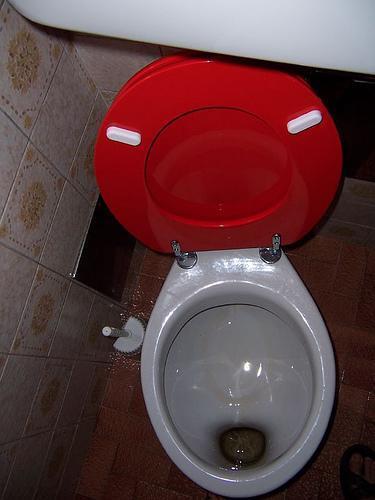How many toilets are in the picture?
Give a very brief answer. 1. 